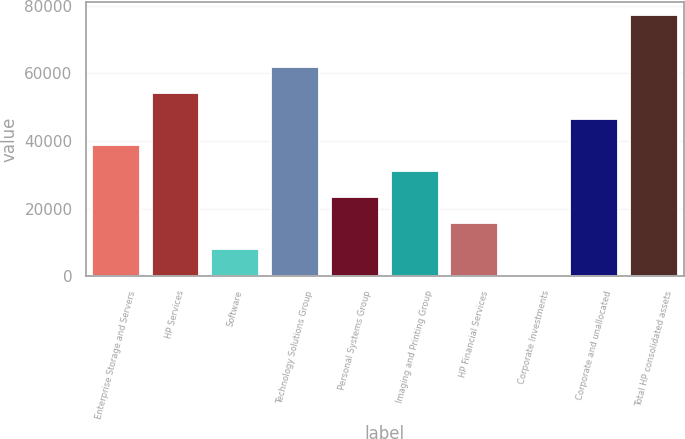<chart> <loc_0><loc_0><loc_500><loc_500><bar_chart><fcel>Enterprise Storage and Servers<fcel>HP Services<fcel>Software<fcel>Technology Solutions Group<fcel>Personal Systems Group<fcel>Imaging and Printing Group<fcel>HP Financial Services<fcel>Corporate Investments<fcel>Corporate and unallocated<fcel>Total HP consolidated assets<nl><fcel>38807<fcel>54211<fcel>7999<fcel>61913<fcel>23403<fcel>31105<fcel>15701<fcel>297<fcel>46509<fcel>77317<nl></chart> 